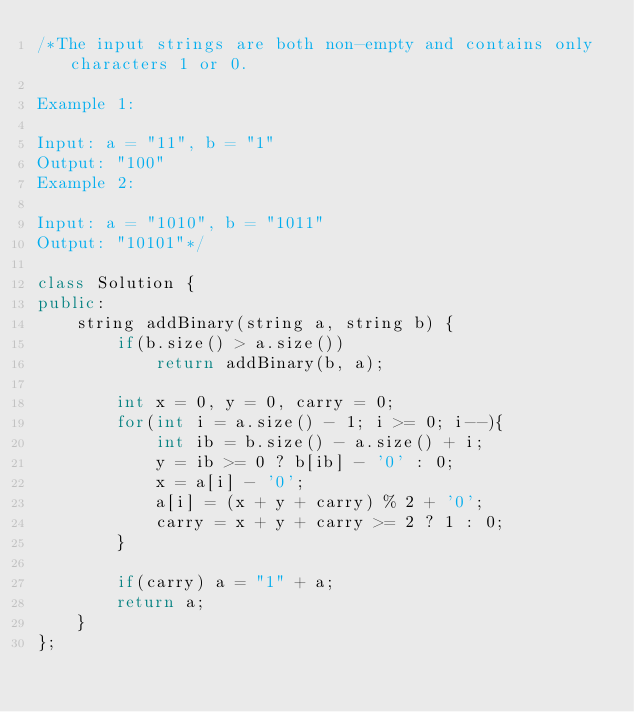Convert code to text. <code><loc_0><loc_0><loc_500><loc_500><_C++_>/*The input strings are both non-empty and contains only characters 1 or 0.

Example 1:

Input: a = "11", b = "1"
Output: "100"
Example 2:

Input: a = "1010", b = "1011"
Output: "10101"*/

class Solution {
public:
    string addBinary(string a, string b) {
        if(b.size() > a.size())
            return addBinary(b, a);
        
        int x = 0, y = 0, carry = 0;
        for(int i = a.size() - 1; i >= 0; i--){
            int ib = b.size() - a.size() + i;
            y = ib >= 0 ? b[ib] - '0' : 0;
            x = a[i] - '0';
            a[i] = (x + y + carry) % 2 + '0';
            carry = x + y + carry >= 2 ? 1 : 0;
        }
        
        if(carry) a = "1" + a;
        return a;
    }
};</code> 